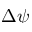Convert formula to latex. <formula><loc_0><loc_0><loc_500><loc_500>\Delta \psi</formula> 